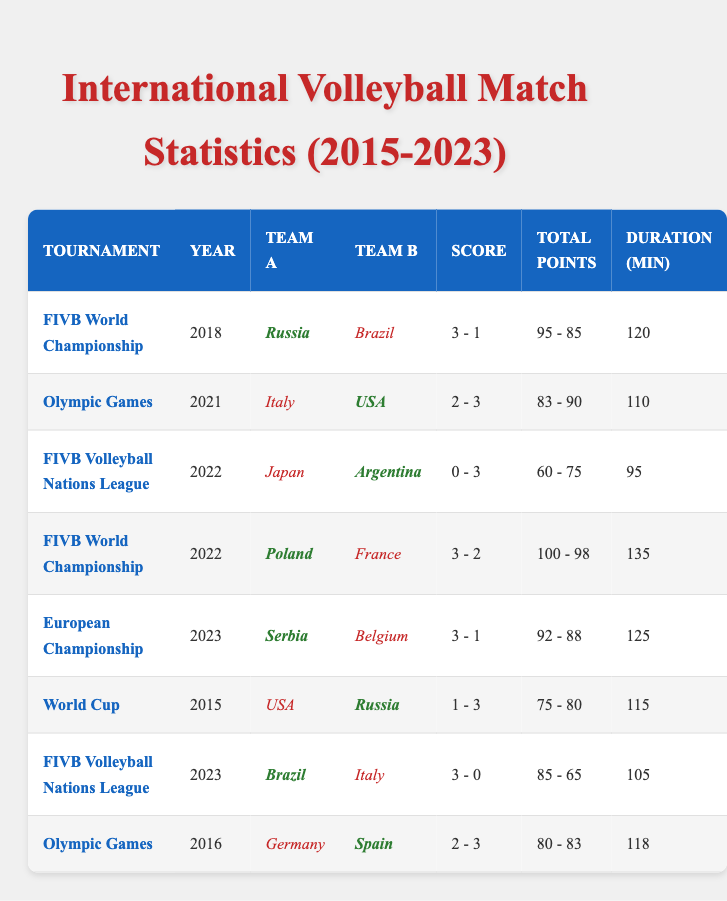What was the longest match duration recorded from the table? By reviewing the "Duration (min)" column, the maximum duration is observed in the match between Poland and France in 2022, which lasted 135 minutes.
Answer: 135 minutes Which team won the match between Russia and Brazil in 2018? Looking at the match details for Russia versus Brazil, it shows that Russia won the match with a score of 3 sets to 1.
Answer: Russia How many points did Serbia score in their match against Belgium in 2023? Checking the points scored by Serbia in their match against Belgium, the table indicates that Serbia scored 92 points.
Answer: 92 points Which tournament had the highest total points scored in a match? To determine the tournament with the highest total points, I sum the points for each match and find that Poland vs. France in the 2022 FIVB World Championship had a total of 198 points (100 + 98), which is the highest.
Answer: FIVB World Championship Is it true that the USA lost to Italy in the Olympic Games of 2021? The result for the USA versus Italy match indicates that Italy lost (sets 2 - 3), so it is false to say the USA lost. The USA actually won the match.
Answer: False What is the average points scored by the winning teams in the matches listed? Summing the points scored by winning teams: 95 (Russia) + 90 (USA) + 75 (Argentina) + 100 (Poland) + 92 (Serbia) + 80 (Russia) + 85 (Brazil) + 83 (Spain) = 800 points across 8 matches, then the average is 800/8 = 100.
Answer: 100 points Which year had the most matches recorded in the table? Counting the number of matches per year reveals there are two matches in the year 2022 (1 for FIVB Volleyball Nations League and 1 for FIVB World Championship), which is the maximum match count for any single year listed.
Answer: 2022 How many matches did Brazil play in total? By reviewing all matches where Brazil is listed either as team A or team B, Brazil played in two matches: one against Russia in 2018 and one against Italy in 2023.
Answer: 2 matches Did Japan win any matches in 2022 according to the table? Looking at Japan's match record, Japan played against Argentina and lost 0 - 3, indicating that Japan did not win any matches in 2022.
Answer: No What is the total number of sets won by teams in the Olympic Games? By adding up all the sets won by teams in Olympic matches, the total is: 3 (USA) + 2 (Italy) + 3 (Spain) + 2 (Germany) = 10 sets won across the listed Olympic matches.
Answer: 10 sets 